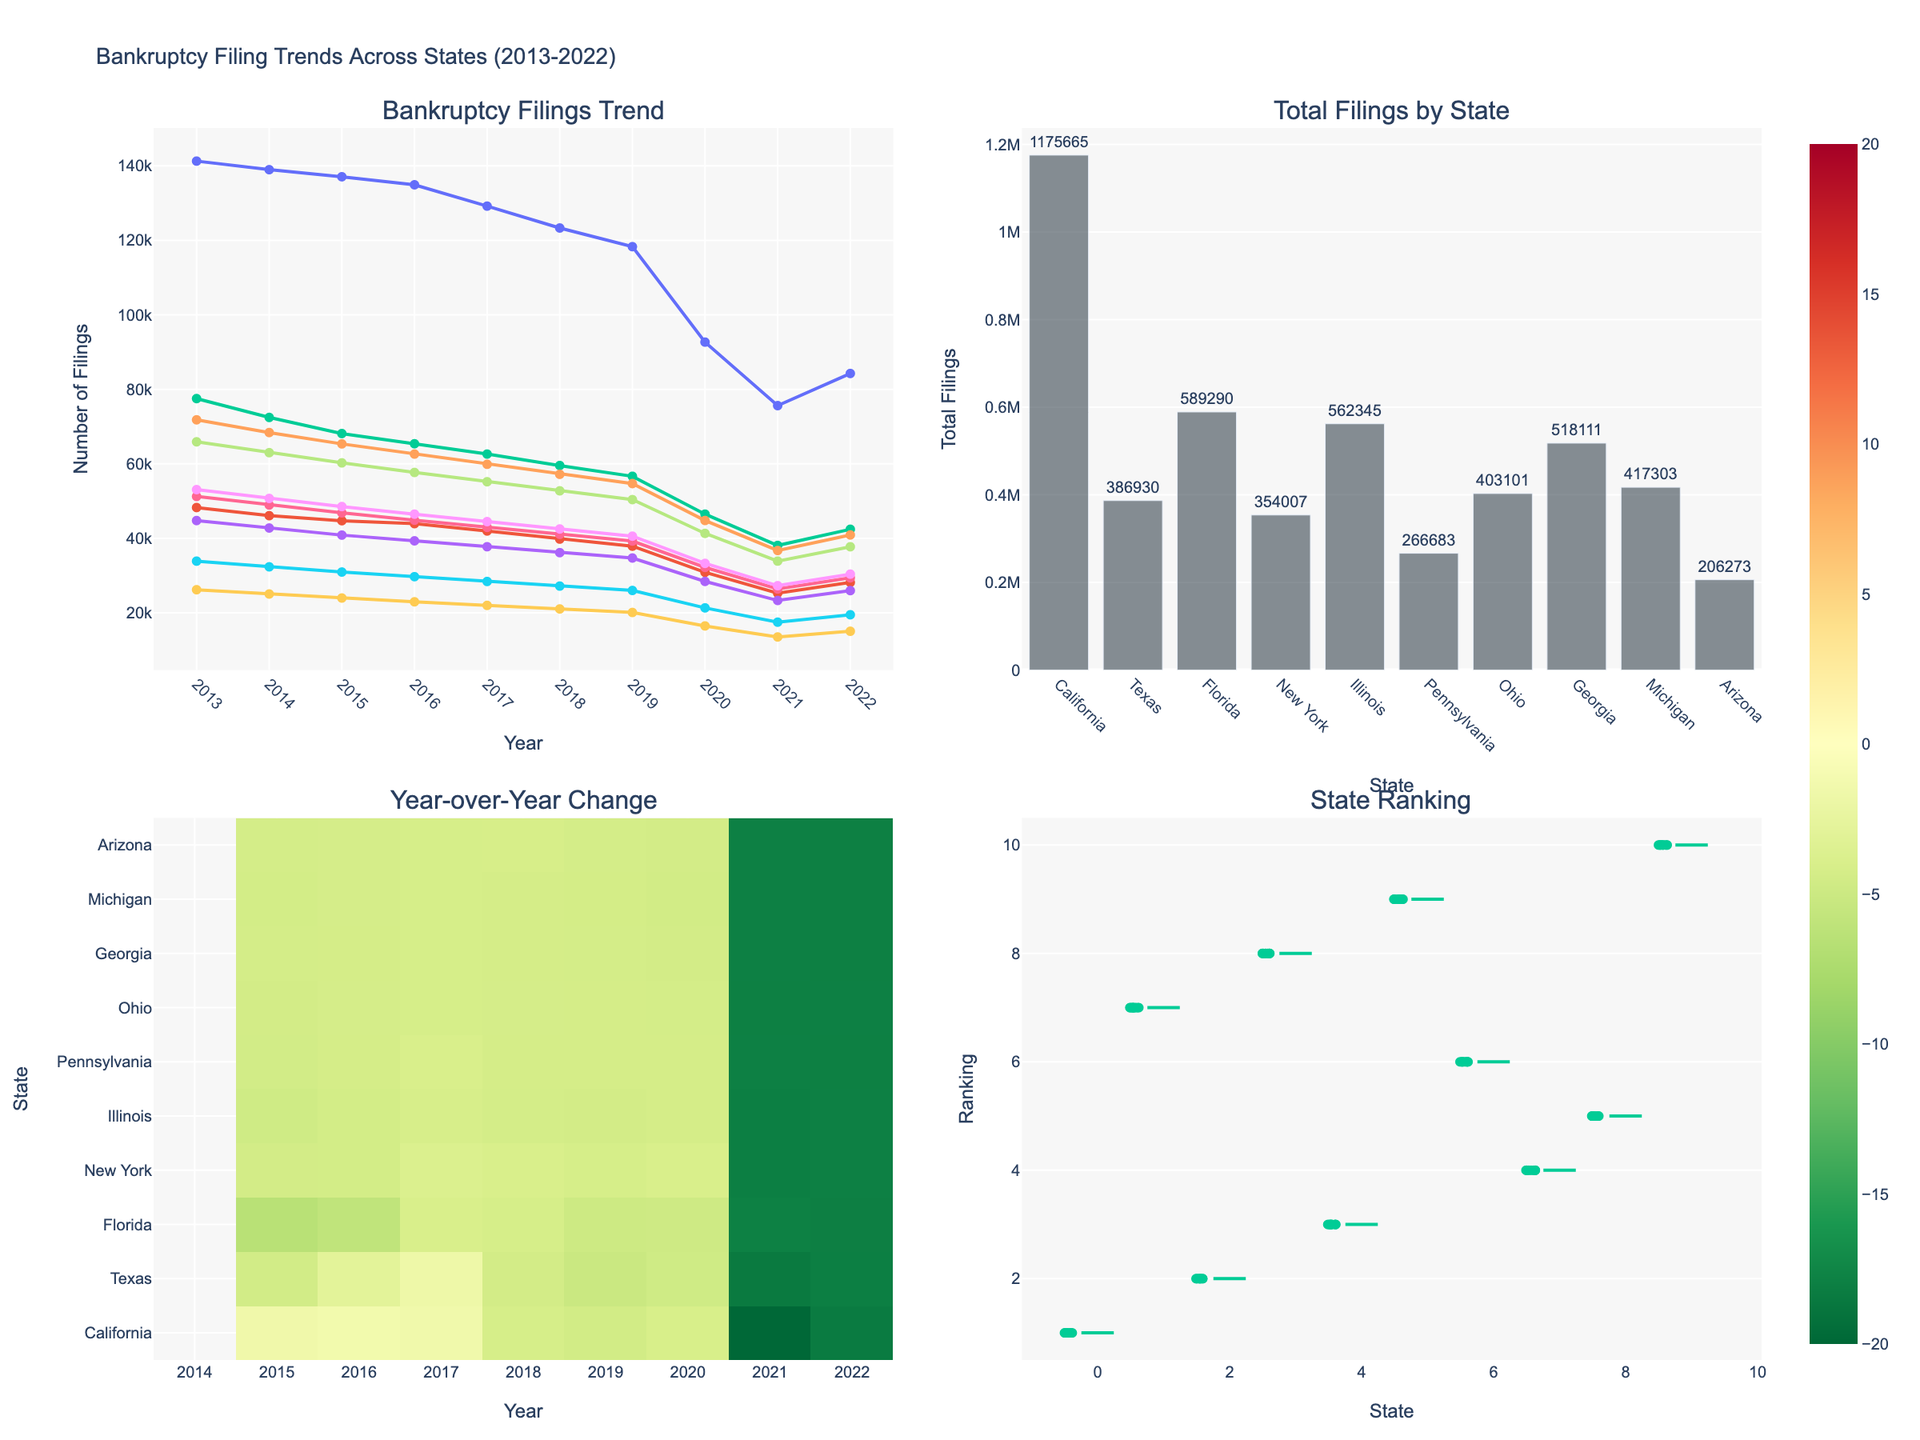What is the title of the figure? The title is located at the top of the figure. It reads "Bankruptcy Filing Trends Across States (2013-2022)."
Answer: Bankruptcy Filing Trends Across States (2013-2022) How many subplots are present in the figure? By visually inspecting the figure, you can see four distinct subplots labeled with unique titles.
Answer: Four Which state has the highest total bankruptcy filings over the past decade? In the second subplot (bar chart), California's bar is the highest. The text position shows its value.
Answer: California Among the states listed, how did the number of bankruptcy filings in Illinois change from 2013 to 2022? Refer to the first subplot (line chart). By comparing the starting point in 2013 for Illinois to its ending point in 2022, the line clearly shows a decrease from approximately 71,815 to around 40,905.
Answer: Decreased Which subplot shows the year-over-year percentage change in bankruptcy filings? The description of each subplot indicates that the heatmap (bottom left) represents the year-over-year change.
Answer: The third subplot (heatmap) Which state had the most consistent decrease in bankruptcy filings from 2013 to 2022? By referencing the first subplot (line chart), states like Illinois and Pennsylvania demonstrate a steady decline in bankruptcy filings across all observed years.
Answer: Illinois Comparing Georgia and Ohio, which state had fewer bankruptcy filings in 2019? Looking at the first subplot (line chart), the point aligned with 2019 shows that Ohio's value is roughly 39,257, which is lower than Georgia's approximate value of 50,389.
Answer: Ohio How does Texas rank in terms of total bankruptcy filings across states for all years? Refer to the second subplot (bar chart). Texas's bar position and its height rank it second, right after California.
Answer: Second What pattern do you observe in the year-over-year change in California's bankruptcy filings? Inspecting the third subplot (heatmap), California consistently shows a decrease, indicated by shades moving towards green, from 2013 to 2022.
Answer: Consistent decrease On the box plot, which state shows the highest variability in rankings? From checking the fourth subplot (box plot), the derivation of the widest spread of rank positions can be seen in states like Michigan.
Answer: Michigan 